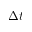Convert formula to latex. <formula><loc_0><loc_0><loc_500><loc_500>\Delta t</formula> 